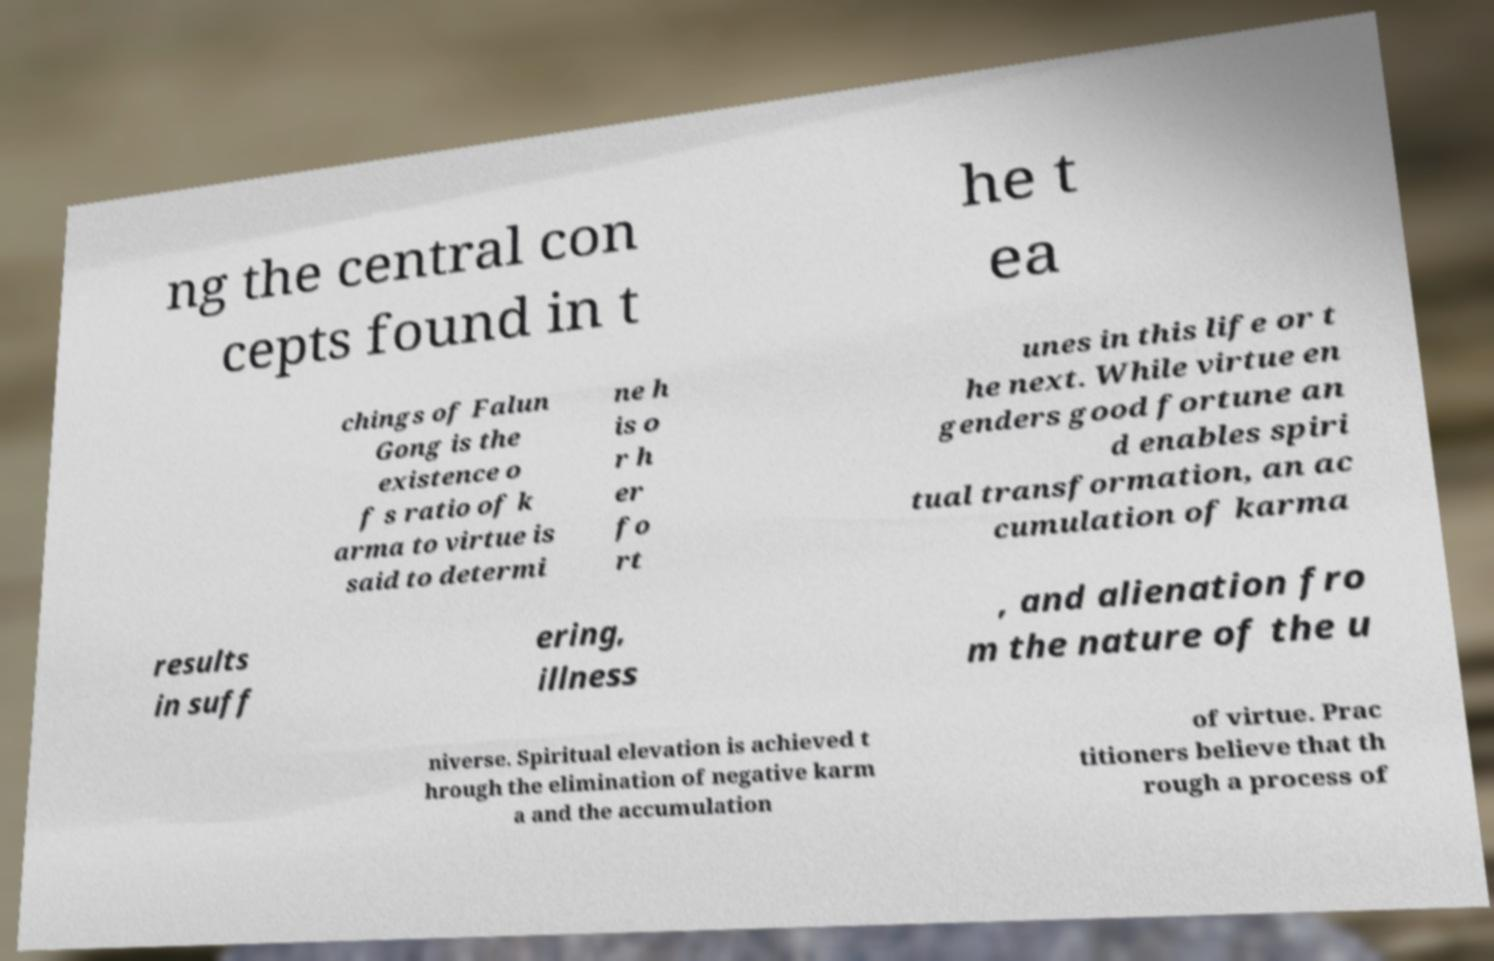What messages or text are displayed in this image? I need them in a readable, typed format. ng the central con cepts found in t he t ea chings of Falun Gong is the existence o f s ratio of k arma to virtue is said to determi ne h is o r h er fo rt unes in this life or t he next. While virtue en genders good fortune an d enables spiri tual transformation, an ac cumulation of karma results in suff ering, illness , and alienation fro m the nature of the u niverse. Spiritual elevation is achieved t hrough the elimination of negative karm a and the accumulation of virtue. Prac titioners believe that th rough a process of 